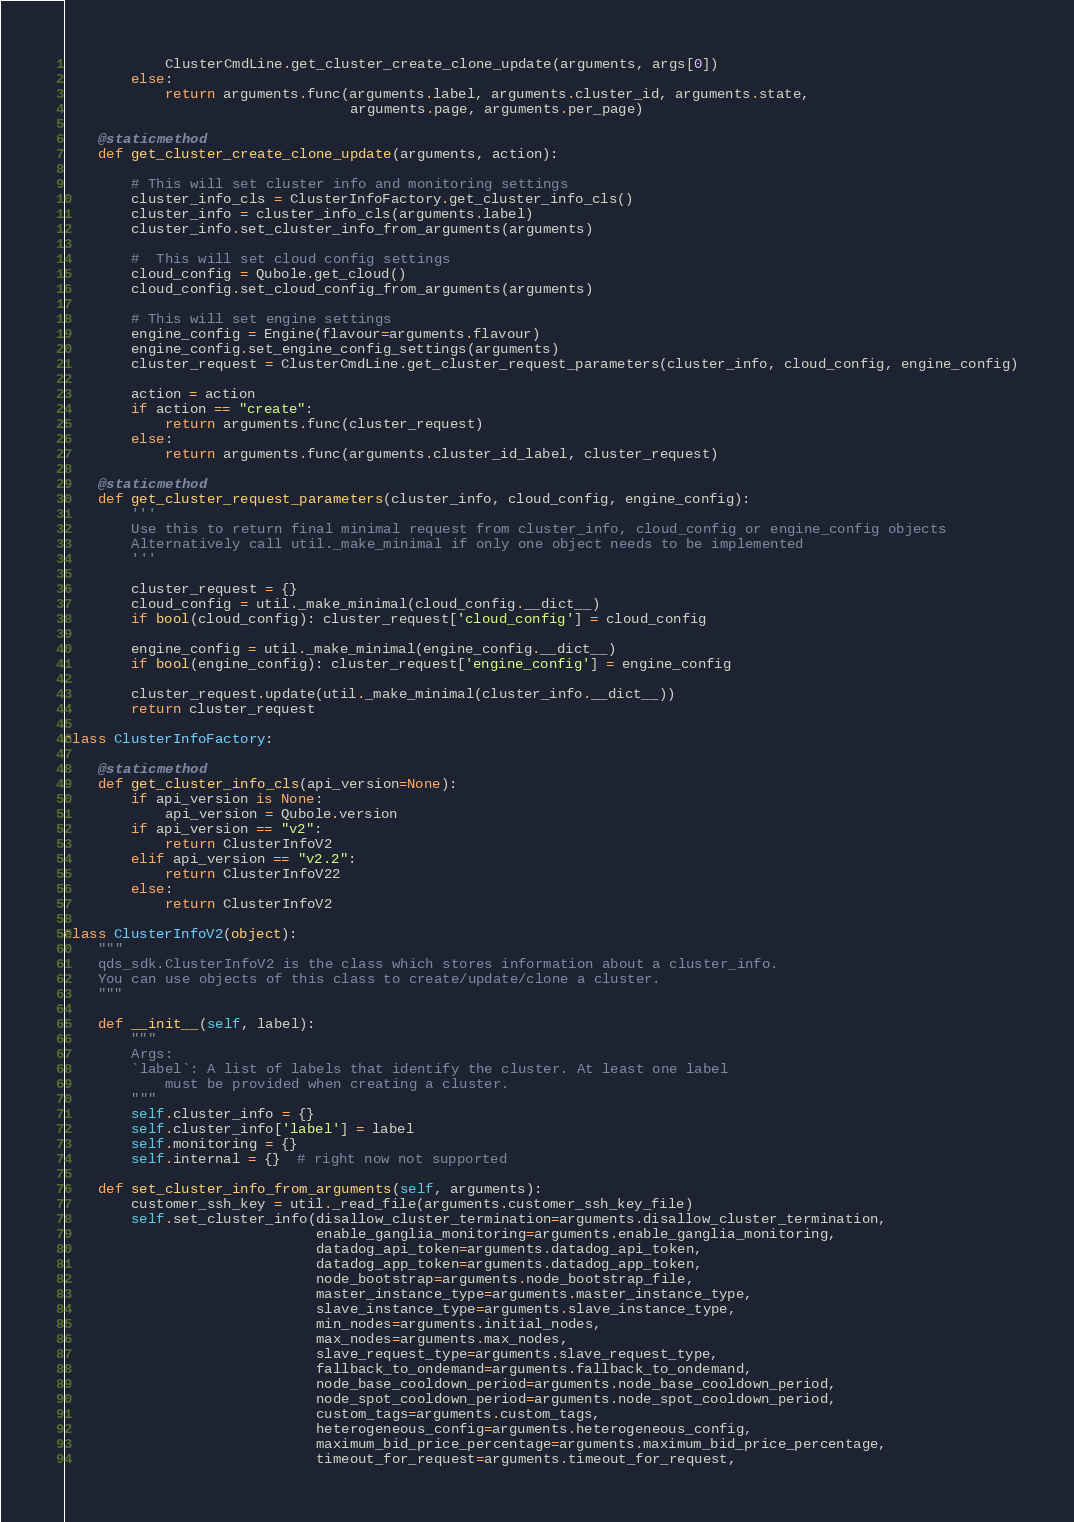Convert code to text. <code><loc_0><loc_0><loc_500><loc_500><_Python_>            ClusterCmdLine.get_cluster_create_clone_update(arguments, args[0])
        else:
            return arguments.func(arguments.label, arguments.cluster_id, arguments.state,
                                  arguments.page, arguments.per_page)

    @staticmethod
    def get_cluster_create_clone_update(arguments, action):

        # This will set cluster info and monitoring settings
        cluster_info_cls = ClusterInfoFactory.get_cluster_info_cls()
        cluster_info = cluster_info_cls(arguments.label)
        cluster_info.set_cluster_info_from_arguments(arguments)

        #  This will set cloud config settings
        cloud_config = Qubole.get_cloud()
        cloud_config.set_cloud_config_from_arguments(arguments)

        # This will set engine settings
        engine_config = Engine(flavour=arguments.flavour)
        engine_config.set_engine_config_settings(arguments)
        cluster_request = ClusterCmdLine.get_cluster_request_parameters(cluster_info, cloud_config, engine_config)

        action = action
        if action == "create":
            return arguments.func(cluster_request)
        else:
            return arguments.func(arguments.cluster_id_label, cluster_request)

    @staticmethod
    def get_cluster_request_parameters(cluster_info, cloud_config, engine_config):
        '''
        Use this to return final minimal request from cluster_info, cloud_config or engine_config objects
        Alternatively call util._make_minimal if only one object needs to be implemented
        '''

        cluster_request = {}
        cloud_config = util._make_minimal(cloud_config.__dict__)
        if bool(cloud_config): cluster_request['cloud_config'] = cloud_config

        engine_config = util._make_minimal(engine_config.__dict__)
        if bool(engine_config): cluster_request['engine_config'] = engine_config

        cluster_request.update(util._make_minimal(cluster_info.__dict__))
        return cluster_request

class ClusterInfoFactory:

    @staticmethod
    def get_cluster_info_cls(api_version=None):
        if api_version is None:
            api_version = Qubole.version
        if api_version == "v2":
            return ClusterInfoV2
        elif api_version == "v2.2":
            return ClusterInfoV22
        else:
            return ClusterInfoV2

class ClusterInfoV2(object):
    """
    qds_sdk.ClusterInfoV2 is the class which stores information about a cluster_info.
    You can use objects of this class to create/update/clone a cluster.
    """

    def __init__(self, label):
        """
        Args:
        `label`: A list of labels that identify the cluster. At least one label
            must be provided when creating a cluster.
        """
        self.cluster_info = {}
        self.cluster_info['label'] = label
        self.monitoring = {}
        self.internal = {}  # right now not supported

    def set_cluster_info_from_arguments(self, arguments):
        customer_ssh_key = util._read_file(arguments.customer_ssh_key_file)
        self.set_cluster_info(disallow_cluster_termination=arguments.disallow_cluster_termination,
                              enable_ganglia_monitoring=arguments.enable_ganglia_monitoring,
                              datadog_api_token=arguments.datadog_api_token,
                              datadog_app_token=arguments.datadog_app_token,
                              node_bootstrap=arguments.node_bootstrap_file,
                              master_instance_type=arguments.master_instance_type,
                              slave_instance_type=arguments.slave_instance_type,
                              min_nodes=arguments.initial_nodes,
                              max_nodes=arguments.max_nodes,
                              slave_request_type=arguments.slave_request_type,
                              fallback_to_ondemand=arguments.fallback_to_ondemand,
                              node_base_cooldown_period=arguments.node_base_cooldown_period,
                              node_spot_cooldown_period=arguments.node_spot_cooldown_period,
                              custom_tags=arguments.custom_tags,
                              heterogeneous_config=arguments.heterogeneous_config,
                              maximum_bid_price_percentage=arguments.maximum_bid_price_percentage,
                              timeout_for_request=arguments.timeout_for_request,</code> 